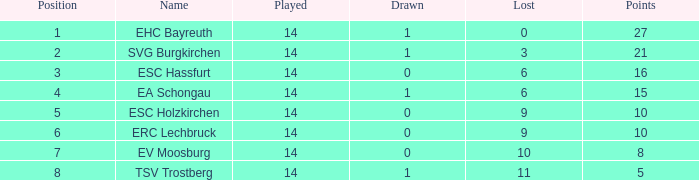What's the deficit when there were over 16 points and had a tie below 1? None. 